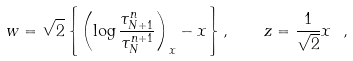<formula> <loc_0><loc_0><loc_500><loc_500>w = \sqrt { 2 } \left \{ \left ( \log \frac { \tau _ { N + 1 } ^ { n } } { \tau _ { N } ^ { n + 1 } } \right ) _ { x } - x \right \} , \quad z = \frac { 1 } { \sqrt { 2 } } x \ ,</formula> 